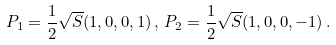<formula> <loc_0><loc_0><loc_500><loc_500>P _ { 1 } = { \frac { 1 } { 2 } } \sqrt { S } ( 1 , 0 , 0 , 1 ) \, , \, P _ { 2 } = { \frac { 1 } { 2 } } \sqrt { S } ( 1 , 0 , 0 , - 1 ) \, . \,</formula> 